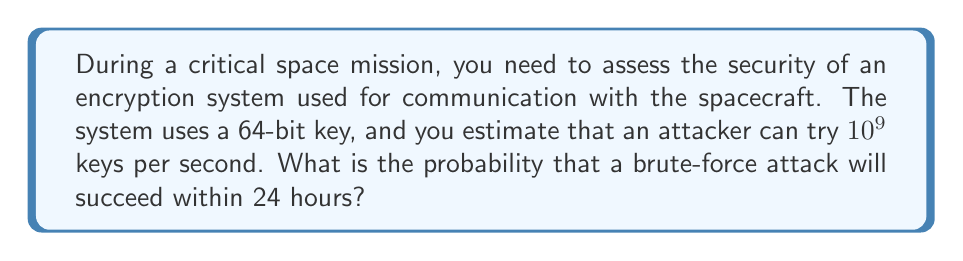Give your solution to this math problem. Let's approach this step-by-step:

1) First, we need to calculate the total number of possible keys:
   $$ \text{Total keys} = 2^{64} $$

2) Next, we calculate how many keys can be tried in 24 hours:
   $$ \text{Keys per second} = 10^9 $$
   $$ \text{Seconds in 24 hours} = 24 \times 60 \times 60 = 86,400 $$
   $$ \text{Keys tried in 24 hours} = 10^9 \times 86,400 = 8.64 \times 10^{13} $$

3) The probability of success is the number of keys that can be tried divided by the total number of possible keys:

   $$ P(\text{success}) = \frac{\text{Keys tried in 24 hours}}{\text{Total keys}} $$

4) Substituting the values:

   $$ P(\text{success}) = \frac{8.64 \times 10^{13}}{2^{64}} $$

5) To calculate this, let's convert $2^{64}$ to base 10:
   $$ 2^{64} \approx 1.8447 \times 10^{19} $$

6) Now we can divide:

   $$ P(\text{success}) = \frac{8.64 \times 10^{13}}{1.8447 \times 10^{19}} \approx 4.684 \times 10^{-6} $$

This is approximately 0.0004684% or about 1 in 2,135,000.
Answer: $4.684 \times 10^{-6}$ 